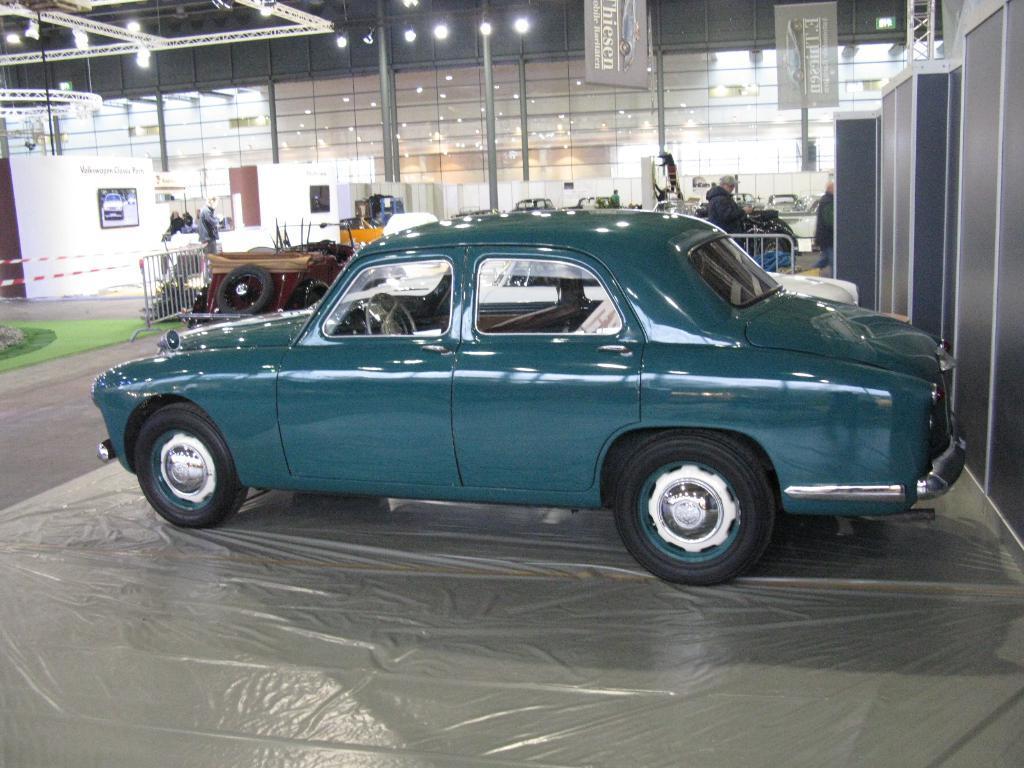Please provide a concise description of this image. In this image I see number of cars and I see few people and I see the poles and banners on which there are words written and I see the lights and I see the path. Over here I see a photo of a car. 